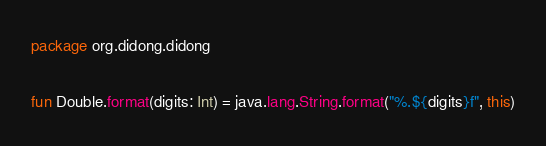Convert code to text. <code><loc_0><loc_0><loc_500><loc_500><_Kotlin_>package org.didong.didong

fun Double.format(digits: Int) = java.lang.String.format("%.${digits}f", this)</code> 